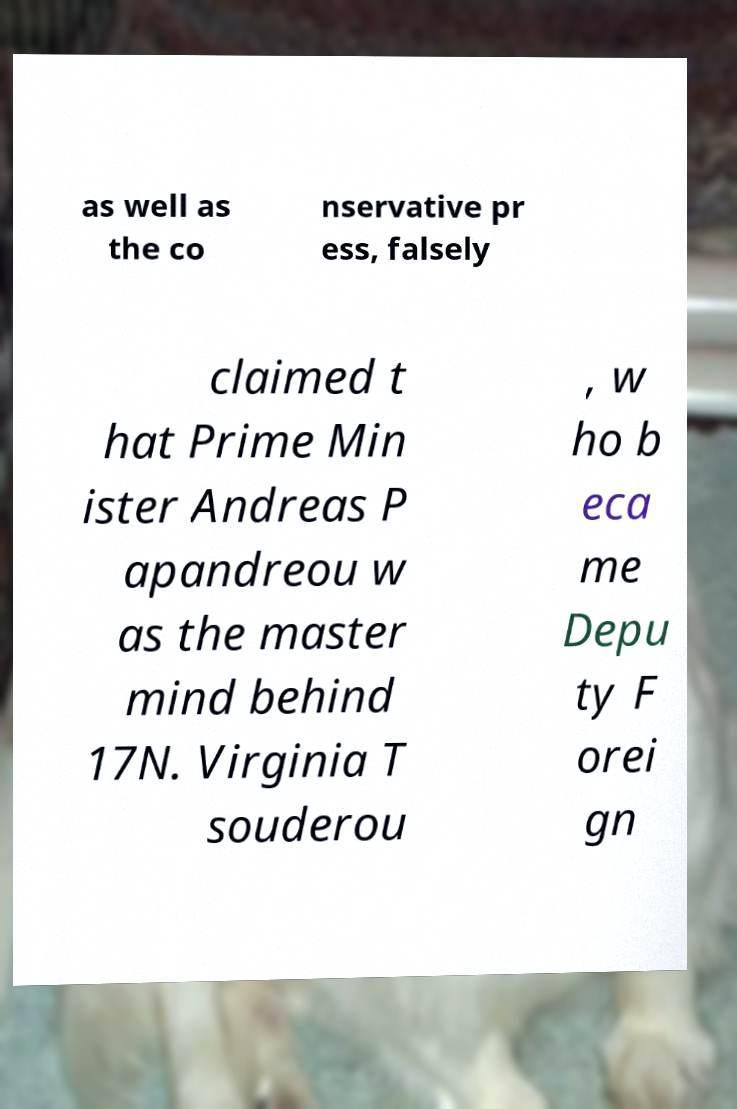What messages or text are displayed in this image? I need them in a readable, typed format. as well as the co nservative pr ess, falsely claimed t hat Prime Min ister Andreas P apandreou w as the master mind behind 17N. Virginia T souderou , w ho b eca me Depu ty F orei gn 